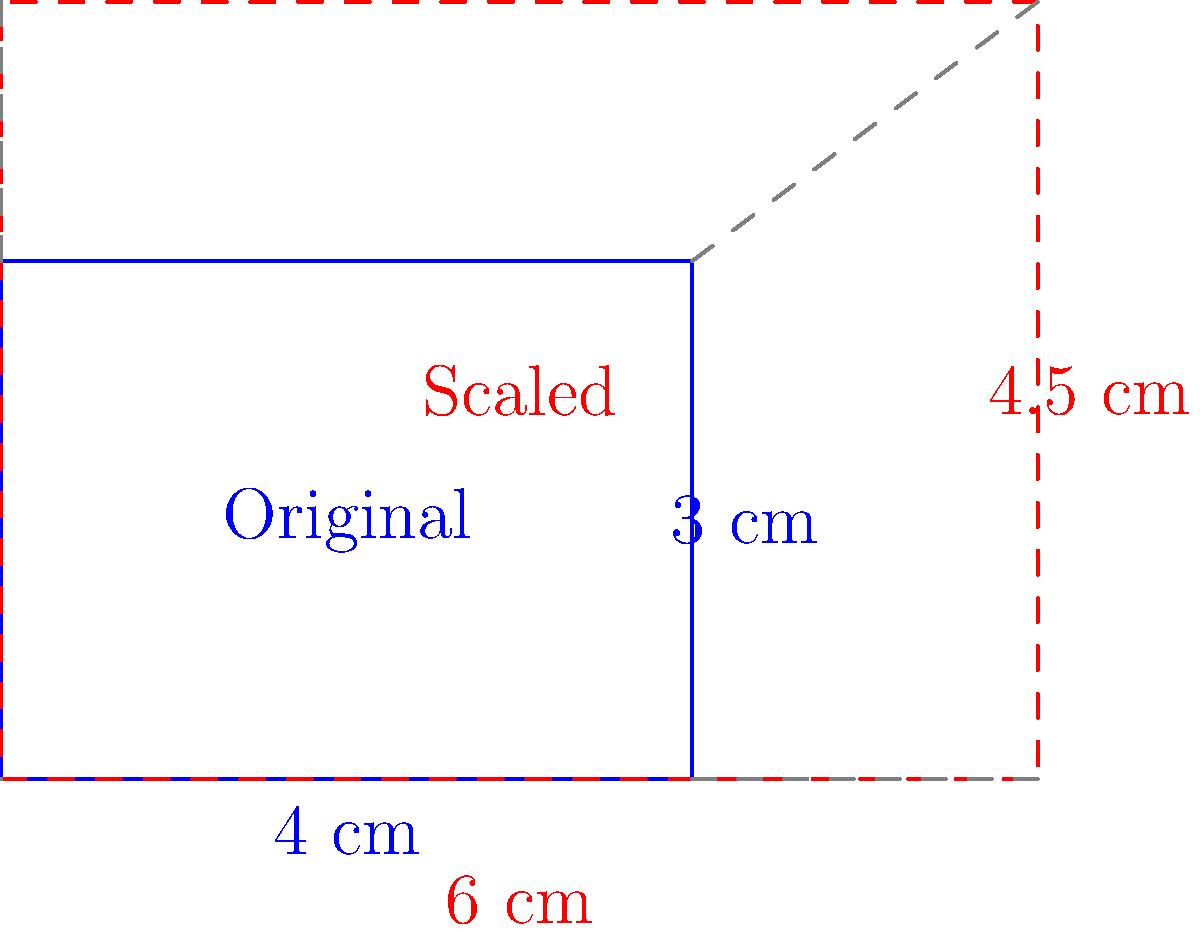A multinational corporation is planning to scale up its product packaging design for the Slovak market. The original design has dimensions of 4 cm x 3 cm. If the company needs to increase the packaging size by 50% to meet Slovak standards, what will be the dimensions of the new packaging design? Express your answer in the form (width, height) in centimeters. To solve this problem, we need to apply a scaling transformation to the original packaging dimensions. Here's a step-by-step approach:

1. Identify the original dimensions:
   Width = 4 cm
   Height = 3 cm

2. Calculate the scaling factor:
   A 50% increase means multiplying the original dimensions by 1.5

3. Apply the scaling factor to the width:
   New width = Original width × Scaling factor
   New width = 4 cm × 1.5 = 6 cm

4. Apply the scaling factor to the height:
   New height = Original height × Scaling factor
   New height = 3 cm × 1.5 = 4.5 cm

5. Express the new dimensions as an ordered pair:
   (New width, New height) = (6 cm, 4.5 cm)

This transformation maintains the aspect ratio of the original design while increasing its size to meet the new market standards.
Answer: (6, 4.5) 